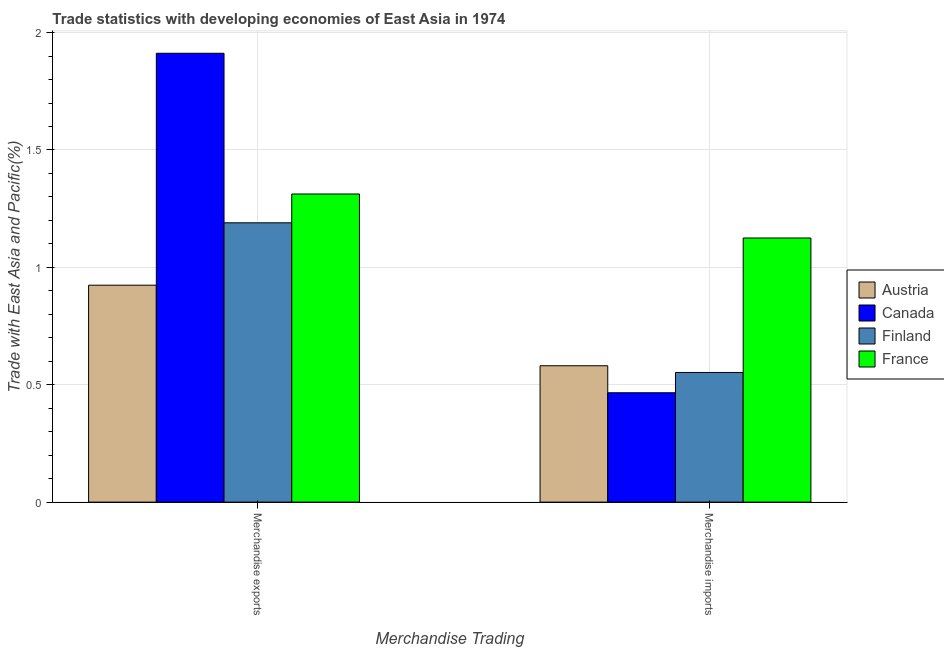How many groups of bars are there?
Ensure brevity in your answer.  2. Are the number of bars per tick equal to the number of legend labels?
Keep it short and to the point. Yes. What is the label of the 2nd group of bars from the left?
Offer a terse response. Merchandise imports. What is the merchandise imports in Finland?
Provide a succinct answer. 0.55. Across all countries, what is the maximum merchandise exports?
Your response must be concise. 1.91. Across all countries, what is the minimum merchandise exports?
Keep it short and to the point. 0.92. In which country was the merchandise exports maximum?
Ensure brevity in your answer.  Canada. What is the total merchandise imports in the graph?
Your response must be concise. 2.72. What is the difference between the merchandise imports in Finland and that in Canada?
Provide a short and direct response. 0.09. What is the difference between the merchandise imports in Austria and the merchandise exports in Finland?
Provide a succinct answer. -0.61. What is the average merchandise exports per country?
Make the answer very short. 1.33. What is the difference between the merchandise exports and merchandise imports in Austria?
Your response must be concise. 0.34. In how many countries, is the merchandise exports greater than 1.9 %?
Keep it short and to the point. 1. What is the ratio of the merchandise imports in Canada to that in Finland?
Ensure brevity in your answer.  0.84. In how many countries, is the merchandise imports greater than the average merchandise imports taken over all countries?
Your response must be concise. 1. What does the 4th bar from the right in Merchandise imports represents?
Ensure brevity in your answer.  Austria. How many countries are there in the graph?
Offer a terse response. 4. What is the difference between two consecutive major ticks on the Y-axis?
Your answer should be very brief. 0.5. Are the values on the major ticks of Y-axis written in scientific E-notation?
Keep it short and to the point. No. Does the graph contain any zero values?
Offer a very short reply. No. Does the graph contain grids?
Provide a short and direct response. Yes. Where does the legend appear in the graph?
Provide a short and direct response. Center right. How many legend labels are there?
Provide a succinct answer. 4. How are the legend labels stacked?
Ensure brevity in your answer.  Vertical. What is the title of the graph?
Offer a very short reply. Trade statistics with developing economies of East Asia in 1974. What is the label or title of the X-axis?
Provide a succinct answer. Merchandise Trading. What is the label or title of the Y-axis?
Offer a very short reply. Trade with East Asia and Pacific(%). What is the Trade with East Asia and Pacific(%) of Austria in Merchandise exports?
Your response must be concise. 0.92. What is the Trade with East Asia and Pacific(%) in Canada in Merchandise exports?
Provide a short and direct response. 1.91. What is the Trade with East Asia and Pacific(%) of Finland in Merchandise exports?
Give a very brief answer. 1.19. What is the Trade with East Asia and Pacific(%) in France in Merchandise exports?
Your answer should be very brief. 1.31. What is the Trade with East Asia and Pacific(%) in Austria in Merchandise imports?
Keep it short and to the point. 0.58. What is the Trade with East Asia and Pacific(%) of Canada in Merchandise imports?
Your answer should be very brief. 0.47. What is the Trade with East Asia and Pacific(%) of Finland in Merchandise imports?
Your answer should be very brief. 0.55. What is the Trade with East Asia and Pacific(%) in France in Merchandise imports?
Your response must be concise. 1.13. Across all Merchandise Trading, what is the maximum Trade with East Asia and Pacific(%) in Austria?
Provide a short and direct response. 0.92. Across all Merchandise Trading, what is the maximum Trade with East Asia and Pacific(%) in Canada?
Your answer should be compact. 1.91. Across all Merchandise Trading, what is the maximum Trade with East Asia and Pacific(%) in Finland?
Provide a short and direct response. 1.19. Across all Merchandise Trading, what is the maximum Trade with East Asia and Pacific(%) of France?
Your response must be concise. 1.31. Across all Merchandise Trading, what is the minimum Trade with East Asia and Pacific(%) of Austria?
Give a very brief answer. 0.58. Across all Merchandise Trading, what is the minimum Trade with East Asia and Pacific(%) in Canada?
Ensure brevity in your answer.  0.47. Across all Merchandise Trading, what is the minimum Trade with East Asia and Pacific(%) of Finland?
Give a very brief answer. 0.55. Across all Merchandise Trading, what is the minimum Trade with East Asia and Pacific(%) of France?
Your answer should be very brief. 1.13. What is the total Trade with East Asia and Pacific(%) of Austria in the graph?
Your answer should be compact. 1.5. What is the total Trade with East Asia and Pacific(%) in Canada in the graph?
Make the answer very short. 2.38. What is the total Trade with East Asia and Pacific(%) of Finland in the graph?
Make the answer very short. 1.74. What is the total Trade with East Asia and Pacific(%) of France in the graph?
Your answer should be compact. 2.44. What is the difference between the Trade with East Asia and Pacific(%) in Austria in Merchandise exports and that in Merchandise imports?
Keep it short and to the point. 0.34. What is the difference between the Trade with East Asia and Pacific(%) of Canada in Merchandise exports and that in Merchandise imports?
Offer a very short reply. 1.45. What is the difference between the Trade with East Asia and Pacific(%) of Finland in Merchandise exports and that in Merchandise imports?
Offer a terse response. 0.64. What is the difference between the Trade with East Asia and Pacific(%) of France in Merchandise exports and that in Merchandise imports?
Your answer should be very brief. 0.19. What is the difference between the Trade with East Asia and Pacific(%) in Austria in Merchandise exports and the Trade with East Asia and Pacific(%) in Canada in Merchandise imports?
Make the answer very short. 0.46. What is the difference between the Trade with East Asia and Pacific(%) in Austria in Merchandise exports and the Trade with East Asia and Pacific(%) in Finland in Merchandise imports?
Make the answer very short. 0.37. What is the difference between the Trade with East Asia and Pacific(%) in Austria in Merchandise exports and the Trade with East Asia and Pacific(%) in France in Merchandise imports?
Keep it short and to the point. -0.2. What is the difference between the Trade with East Asia and Pacific(%) of Canada in Merchandise exports and the Trade with East Asia and Pacific(%) of Finland in Merchandise imports?
Offer a terse response. 1.36. What is the difference between the Trade with East Asia and Pacific(%) of Canada in Merchandise exports and the Trade with East Asia and Pacific(%) of France in Merchandise imports?
Your answer should be compact. 0.79. What is the difference between the Trade with East Asia and Pacific(%) of Finland in Merchandise exports and the Trade with East Asia and Pacific(%) of France in Merchandise imports?
Give a very brief answer. 0.06. What is the average Trade with East Asia and Pacific(%) in Austria per Merchandise Trading?
Provide a succinct answer. 0.75. What is the average Trade with East Asia and Pacific(%) of Canada per Merchandise Trading?
Offer a very short reply. 1.19. What is the average Trade with East Asia and Pacific(%) in Finland per Merchandise Trading?
Your answer should be very brief. 0.87. What is the average Trade with East Asia and Pacific(%) of France per Merchandise Trading?
Provide a short and direct response. 1.22. What is the difference between the Trade with East Asia and Pacific(%) of Austria and Trade with East Asia and Pacific(%) of Canada in Merchandise exports?
Provide a short and direct response. -0.99. What is the difference between the Trade with East Asia and Pacific(%) in Austria and Trade with East Asia and Pacific(%) in Finland in Merchandise exports?
Your answer should be very brief. -0.27. What is the difference between the Trade with East Asia and Pacific(%) in Austria and Trade with East Asia and Pacific(%) in France in Merchandise exports?
Your answer should be very brief. -0.39. What is the difference between the Trade with East Asia and Pacific(%) in Canada and Trade with East Asia and Pacific(%) in Finland in Merchandise exports?
Give a very brief answer. 0.72. What is the difference between the Trade with East Asia and Pacific(%) in Canada and Trade with East Asia and Pacific(%) in France in Merchandise exports?
Give a very brief answer. 0.6. What is the difference between the Trade with East Asia and Pacific(%) of Finland and Trade with East Asia and Pacific(%) of France in Merchandise exports?
Your response must be concise. -0.12. What is the difference between the Trade with East Asia and Pacific(%) of Austria and Trade with East Asia and Pacific(%) of Canada in Merchandise imports?
Offer a terse response. 0.12. What is the difference between the Trade with East Asia and Pacific(%) of Austria and Trade with East Asia and Pacific(%) of Finland in Merchandise imports?
Your response must be concise. 0.03. What is the difference between the Trade with East Asia and Pacific(%) in Austria and Trade with East Asia and Pacific(%) in France in Merchandise imports?
Give a very brief answer. -0.54. What is the difference between the Trade with East Asia and Pacific(%) in Canada and Trade with East Asia and Pacific(%) in Finland in Merchandise imports?
Make the answer very short. -0.09. What is the difference between the Trade with East Asia and Pacific(%) of Canada and Trade with East Asia and Pacific(%) of France in Merchandise imports?
Provide a short and direct response. -0.66. What is the difference between the Trade with East Asia and Pacific(%) of Finland and Trade with East Asia and Pacific(%) of France in Merchandise imports?
Give a very brief answer. -0.57. What is the ratio of the Trade with East Asia and Pacific(%) of Austria in Merchandise exports to that in Merchandise imports?
Provide a short and direct response. 1.59. What is the ratio of the Trade with East Asia and Pacific(%) in Canada in Merchandise exports to that in Merchandise imports?
Your answer should be compact. 4.1. What is the ratio of the Trade with East Asia and Pacific(%) of Finland in Merchandise exports to that in Merchandise imports?
Provide a short and direct response. 2.15. What is the ratio of the Trade with East Asia and Pacific(%) in France in Merchandise exports to that in Merchandise imports?
Your answer should be very brief. 1.17. What is the difference between the highest and the second highest Trade with East Asia and Pacific(%) of Austria?
Offer a terse response. 0.34. What is the difference between the highest and the second highest Trade with East Asia and Pacific(%) of Canada?
Your answer should be compact. 1.45. What is the difference between the highest and the second highest Trade with East Asia and Pacific(%) of Finland?
Your answer should be compact. 0.64. What is the difference between the highest and the second highest Trade with East Asia and Pacific(%) in France?
Make the answer very short. 0.19. What is the difference between the highest and the lowest Trade with East Asia and Pacific(%) of Austria?
Offer a very short reply. 0.34. What is the difference between the highest and the lowest Trade with East Asia and Pacific(%) of Canada?
Ensure brevity in your answer.  1.45. What is the difference between the highest and the lowest Trade with East Asia and Pacific(%) in Finland?
Provide a short and direct response. 0.64. What is the difference between the highest and the lowest Trade with East Asia and Pacific(%) in France?
Give a very brief answer. 0.19. 